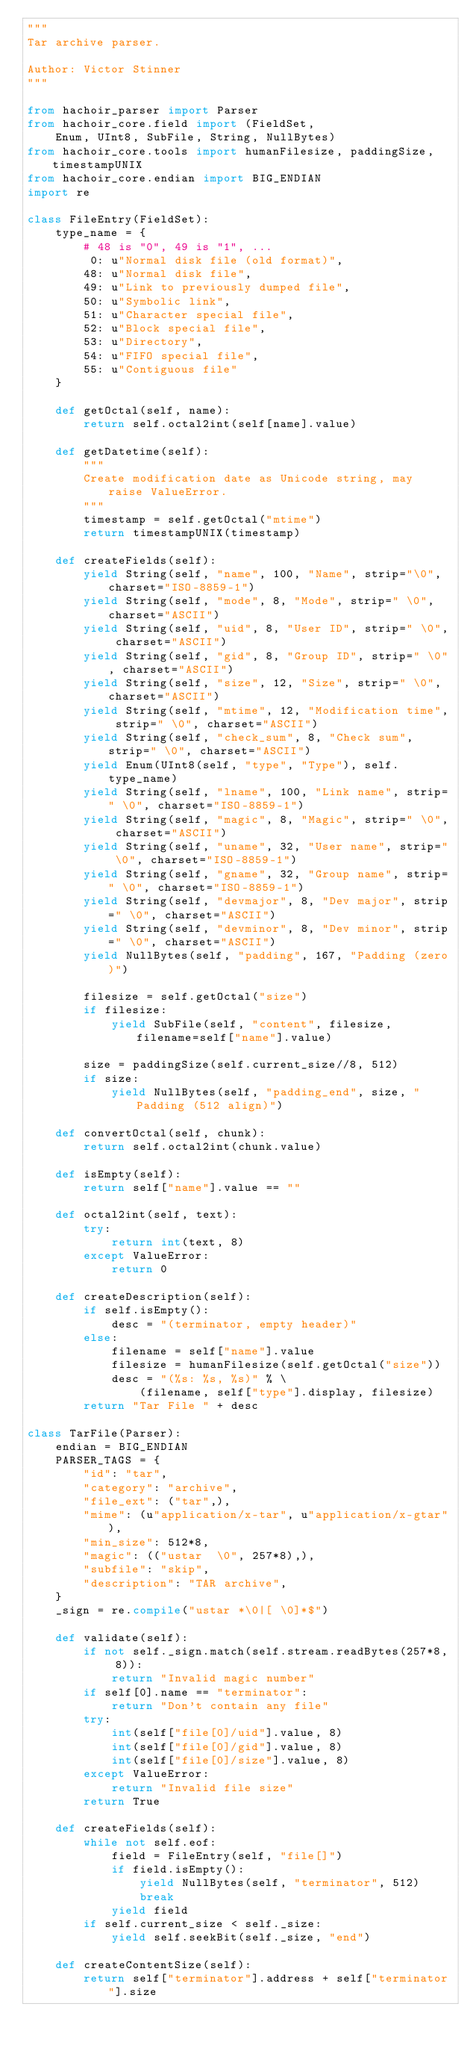<code> <loc_0><loc_0><loc_500><loc_500><_Python_>"""
Tar archive parser.

Author: Victor Stinner
"""

from hachoir_parser import Parser
from hachoir_core.field import (FieldSet,
    Enum, UInt8, SubFile, String, NullBytes)
from hachoir_core.tools import humanFilesize, paddingSize, timestampUNIX
from hachoir_core.endian import BIG_ENDIAN
import re

class FileEntry(FieldSet):
    type_name = {
        # 48 is "0", 49 is "1", ...
         0: u"Normal disk file (old format)",
        48: u"Normal disk file",
        49: u"Link to previously dumped file",
        50: u"Symbolic link",
        51: u"Character special file",
        52: u"Block special file",
        53: u"Directory",
        54: u"FIFO special file",
        55: u"Contiguous file"
    }

    def getOctal(self, name):
        return self.octal2int(self[name].value)

    def getDatetime(self):
        """
        Create modification date as Unicode string, may raise ValueError.
        """
        timestamp = self.getOctal("mtime")
        return timestampUNIX(timestamp)

    def createFields(self):
        yield String(self, "name", 100, "Name", strip="\0", charset="ISO-8859-1")
        yield String(self, "mode", 8, "Mode", strip=" \0", charset="ASCII")
        yield String(self, "uid", 8, "User ID", strip=" \0", charset="ASCII")
        yield String(self, "gid", 8, "Group ID", strip=" \0", charset="ASCII")
        yield String(self, "size", 12, "Size", strip=" \0", charset="ASCII")
        yield String(self, "mtime", 12, "Modification time", strip=" \0", charset="ASCII")
        yield String(self, "check_sum", 8, "Check sum", strip=" \0", charset="ASCII")
        yield Enum(UInt8(self, "type", "Type"), self.type_name)
        yield String(self, "lname", 100, "Link name", strip=" \0", charset="ISO-8859-1")
        yield String(self, "magic", 8, "Magic", strip=" \0", charset="ASCII")
        yield String(self, "uname", 32, "User name", strip=" \0", charset="ISO-8859-1")
        yield String(self, "gname", 32, "Group name", strip=" \0", charset="ISO-8859-1")
        yield String(self, "devmajor", 8, "Dev major", strip=" \0", charset="ASCII")
        yield String(self, "devminor", 8, "Dev minor", strip=" \0", charset="ASCII")
        yield NullBytes(self, "padding", 167, "Padding (zero)")

        filesize = self.getOctal("size")
        if filesize:
            yield SubFile(self, "content", filesize, filename=self["name"].value)

        size = paddingSize(self.current_size//8, 512)
        if size:
            yield NullBytes(self, "padding_end", size, "Padding (512 align)")

    def convertOctal(self, chunk):
        return self.octal2int(chunk.value)

    def isEmpty(self):
        return self["name"].value == ""

    def octal2int(self, text):
        try:
            return int(text, 8)
        except ValueError:
            return 0

    def createDescription(self):
        if self.isEmpty():
            desc = "(terminator, empty header)"
        else:
            filename = self["name"].value
            filesize = humanFilesize(self.getOctal("size"))
            desc = "(%s: %s, %s)" % \
                (filename, self["type"].display, filesize)
        return "Tar File " + desc

class TarFile(Parser):
    endian = BIG_ENDIAN
    PARSER_TAGS = {
        "id": "tar",
        "category": "archive",
        "file_ext": ("tar",),
        "mime": (u"application/x-tar", u"application/x-gtar"),
        "min_size": 512*8,
        "magic": (("ustar  \0", 257*8),),
        "subfile": "skip",
        "description": "TAR archive",
    }
    _sign = re.compile("ustar *\0|[ \0]*$")

    def validate(self):
        if not self._sign.match(self.stream.readBytes(257*8, 8)):
            return "Invalid magic number"
        if self[0].name == "terminator":
            return "Don't contain any file"
        try:
            int(self["file[0]/uid"].value, 8)
            int(self["file[0]/gid"].value, 8)
            int(self["file[0]/size"].value, 8)
        except ValueError:
            return "Invalid file size"
        return True

    def createFields(self):
        while not self.eof:
            field = FileEntry(self, "file[]")
            if field.isEmpty():
                yield NullBytes(self, "terminator", 512)
                break
            yield field
        if self.current_size < self._size:
            yield self.seekBit(self._size, "end")

    def createContentSize(self):
        return self["terminator"].address + self["terminator"].size

</code> 